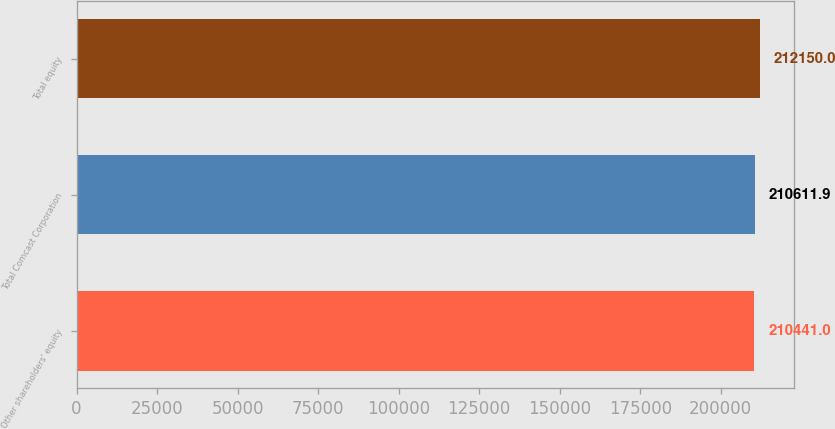Convert chart to OTSL. <chart><loc_0><loc_0><loc_500><loc_500><bar_chart><fcel>Other shareholders' equity<fcel>Total Comcast Corporation<fcel>Total equity<nl><fcel>210441<fcel>210612<fcel>212150<nl></chart> 